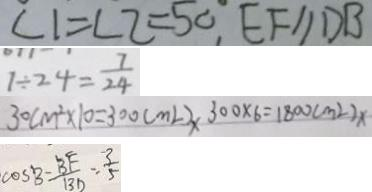Convert formula to latex. <formula><loc_0><loc_0><loc_500><loc_500>\angle 1 = \angle 2 = 5 0 ^ { \circ } , E F / / D B 
 1 \div 2 4 = \frac { 7 } { 2 4 } 
 3 0 c m ^ { 2 } \times 1 0 = 3 0 0 ( m l ) x 3 0 0 \times 6 = 1 8 0 0 ( m ^ { 2 } ) x 
 \cos B - \frac { B F } { B D } = \frac { 3 } { 5 }</formula> 